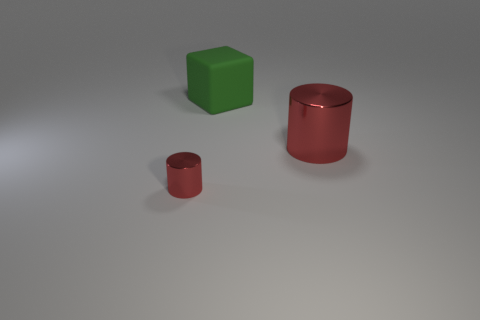Add 2 large green matte objects. How many objects exist? 5 Subtract all cylinders. How many objects are left? 1 Subtract all purple blocks. How many cyan cylinders are left? 0 Add 1 large red things. How many large red things are left? 2 Add 2 cylinders. How many cylinders exist? 4 Subtract 1 green cubes. How many objects are left? 2 Subtract 1 blocks. How many blocks are left? 0 Subtract all gray cubes. Subtract all brown cylinders. How many cubes are left? 1 Subtract all large rubber cubes. Subtract all green cubes. How many objects are left? 1 